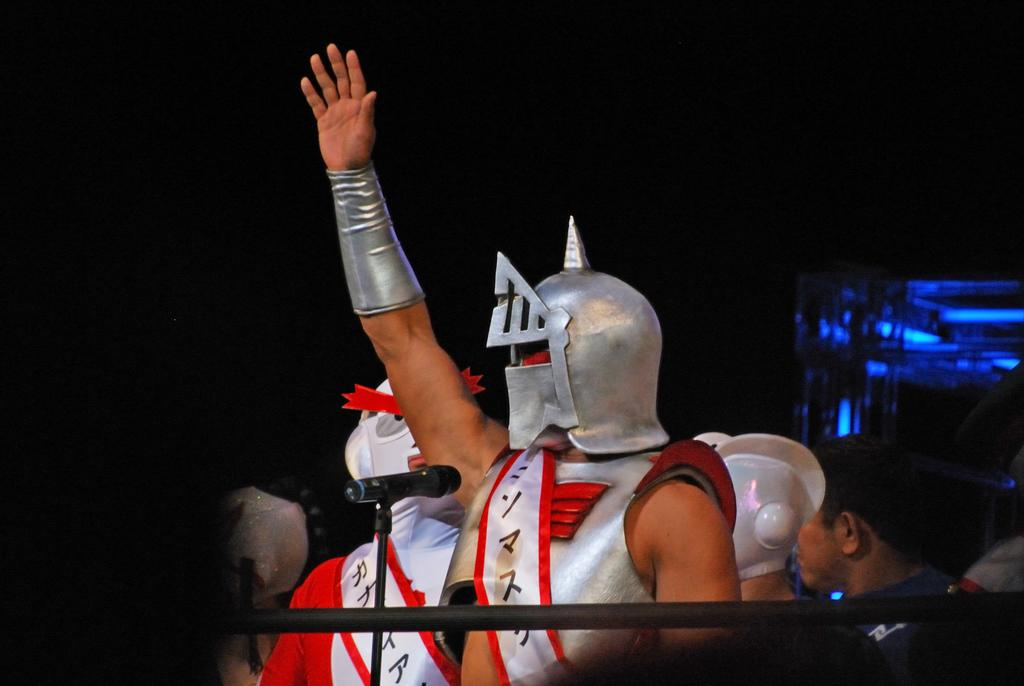How many people are in the image? There is a group of people in the image. Can you describe the attire of one of the individuals? One person is wearing a silver-colored dress. What can be observed about the background of the image? The background of the image is dark. What type of hammer is being used by the women in the image? There are no women or hammers present in the image. 